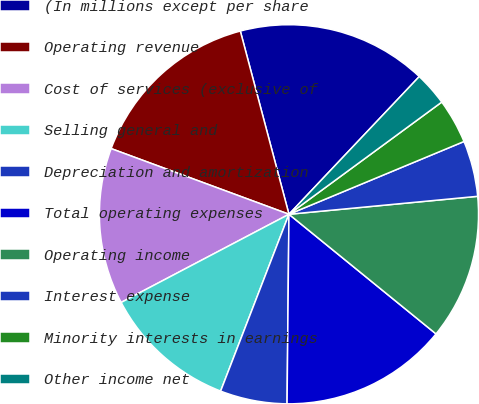Convert chart to OTSL. <chart><loc_0><loc_0><loc_500><loc_500><pie_chart><fcel>(In millions except per share<fcel>Operating revenue<fcel>Cost of services (exclusive of<fcel>Selling general and<fcel>Depreciation and amortization<fcel>Total operating expenses<fcel>Operating income<fcel>Interest expense<fcel>Minority interests in earnings<fcel>Other income net<nl><fcel>16.19%<fcel>15.24%<fcel>13.33%<fcel>11.43%<fcel>5.71%<fcel>14.29%<fcel>12.38%<fcel>4.76%<fcel>3.81%<fcel>2.86%<nl></chart> 